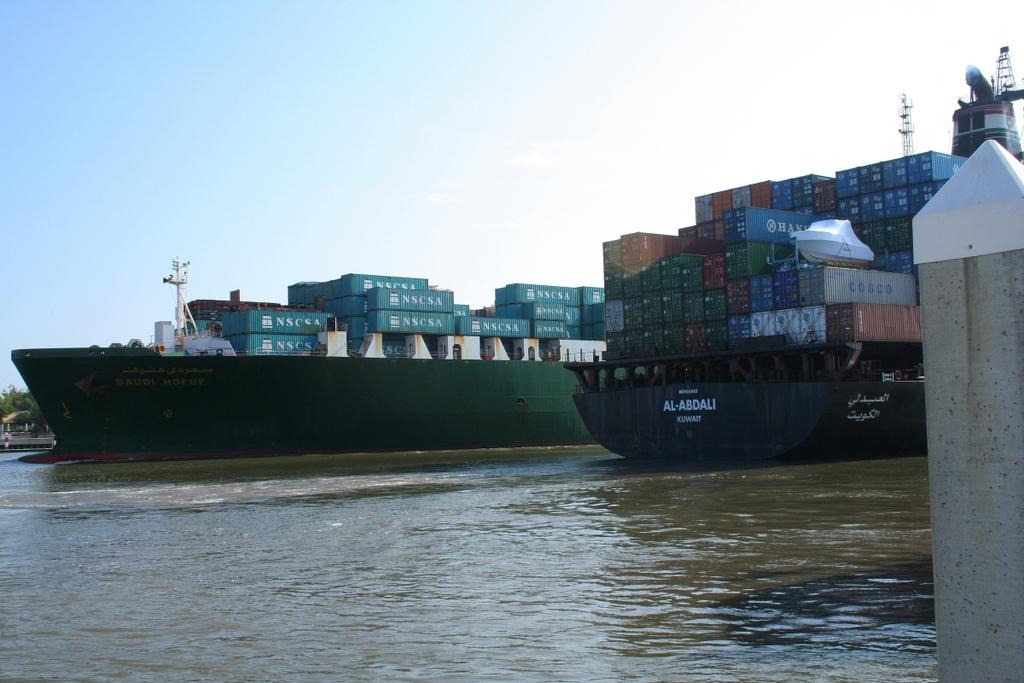<image>
Give a short and clear explanation of the subsequent image. A cargo ship is loaded up with containers that read NSCSA on them. 